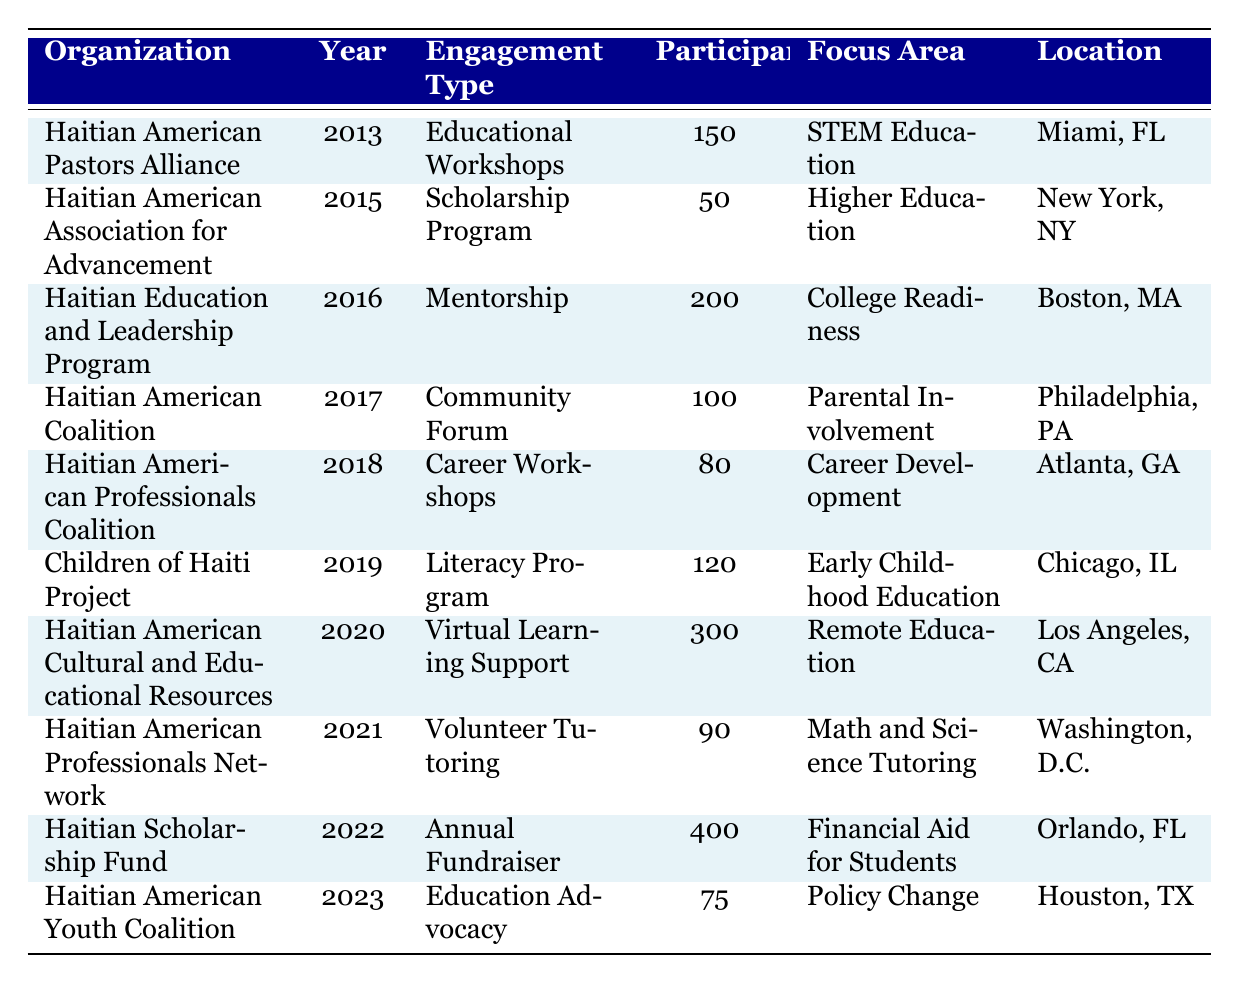What was the engagement type of the Haitian Scholarship Fund in 2022? The table indicates that the "Engagement Type" for the Haitian Scholarship Fund in 2022 is listed as "Annual Fundraiser".
Answer: Annual Fundraiser How many participants were involved in mentoring through the Haitian Education and Leadership Program in 2016? Looking at the row for the Haitian Education and Leadership Program in 2016, it shows that there were 200 participants in the Mentorship.
Answer: 200 Which organization had the highest number of participants in a single event and in what year did it occur? By examining each row, the Haitian American Cultural and Educational Resources had the highest number of participants, which was 300 in the year 2020.
Answer: Haitian American Cultural and Educational Resources, 2020 What focus area did the Haitian American Youth Coalition address in 2023? The data for the Haitian American Youth Coalition in 2023 specifies the focus area as "Policy Change."
Answer: Policy Change How many more participants engaged in the Virtual Learning Support in 2020 compared to the Scholarship Program in 2015? The Virtual Learning Support in 2020 had 300 participants, while the Scholarship Program in 2015 had 50 participants. The difference is 300 - 50 = 250.
Answer: 250 What is the average number of participants across all the events listed in the table? To find the average, first sum all participants: 150 + 50 + 200 + 100 + 80 + 120 + 300 + 90 + 400 + 75 = 1565. There are 10 organizations, so the average is 1565 / 10 = 156.5.
Answer: 156.5 In which location did the Community Forum held by the Haitian American Coalition in 2017 take place? The table shows that the Community Forum by the Haitian American Coalition occurred in Philadelphia, PA, in 2017.
Answer: Philadelphia, PA Was there any educational engagement focusing on STEM Education prior to 2015? The table shows that the Haitian American Pastors Alliance hosted an educational workshop focused on STEM Education in 2013. Therefore, the answer is yes.
Answer: Yes Which organization focused on Early Childhood Education and how many participants did they have? The Children of Haiti Project focused on Early Childhood Education and had 120 participants in 2019.
Answer: Children of Haiti Project, 120 What can be inferred about community engagement in education trends from 2013 to 2023 based on the participants? Analyzing the participant numbers, engagement has generally increased, with significant events like the 400 participants in the Annual Fundraiser in 2022 indicating growing community involvement over the decade.
Answer: General increase in engagement Was the focus area of the Haitian American Professionals Coalition primarily on Higher Education? The Haitian American Professionals Coalition in 2018 focused on Career Development, not Higher Education. Thus, the statement is false.
Answer: False 